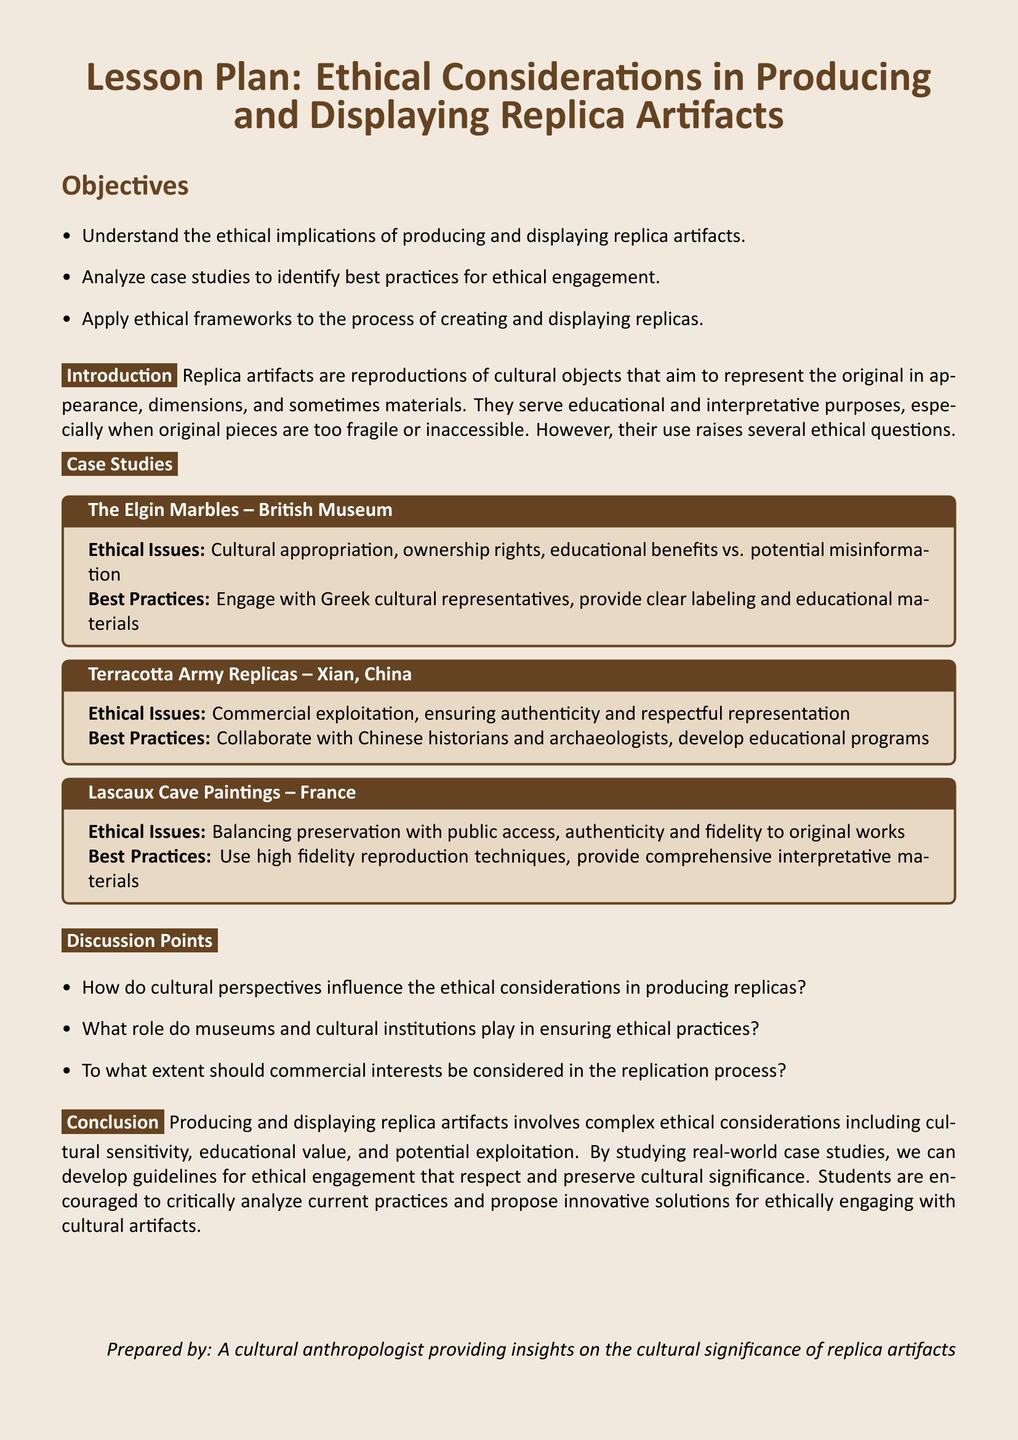what is the title of the lesson plan? The title is clearly stated at the beginning of the document.
Answer: Ethical Considerations in Producing and Displaying Replica Artifacts what are the objectives listed in the document? The objectives are outlined in a bullet list in the document.
Answer: Understand ethical implications, analyze case studies, apply ethical frameworks which case study addresses ethical issues of cultural appropriation? The document specifies case studies with their respective ethical issues.
Answer: The Elgin Marbles – British Museum what is one of the best practices mentioned for the Terracotta Army replicas? Best practices are provided for each case study in the document.
Answer: Collaborate with Chinese historians how many case studies are discussed in the document? The number of case studies can be counted from the section dedicated to them.
Answer: Three how do cultural perspectives influence the ethical considerations? This question prompts reasoning over the discussion points section of the document.
Answer: Cultural perspectives influence ethical considerations who prepared the lesson plan? The document credits the preparation to a specific individual in the closing section.
Answer: A cultural anthropologist what color is used for the page background? The color of the page background is mentioned in the document.
Answer: Light brown 